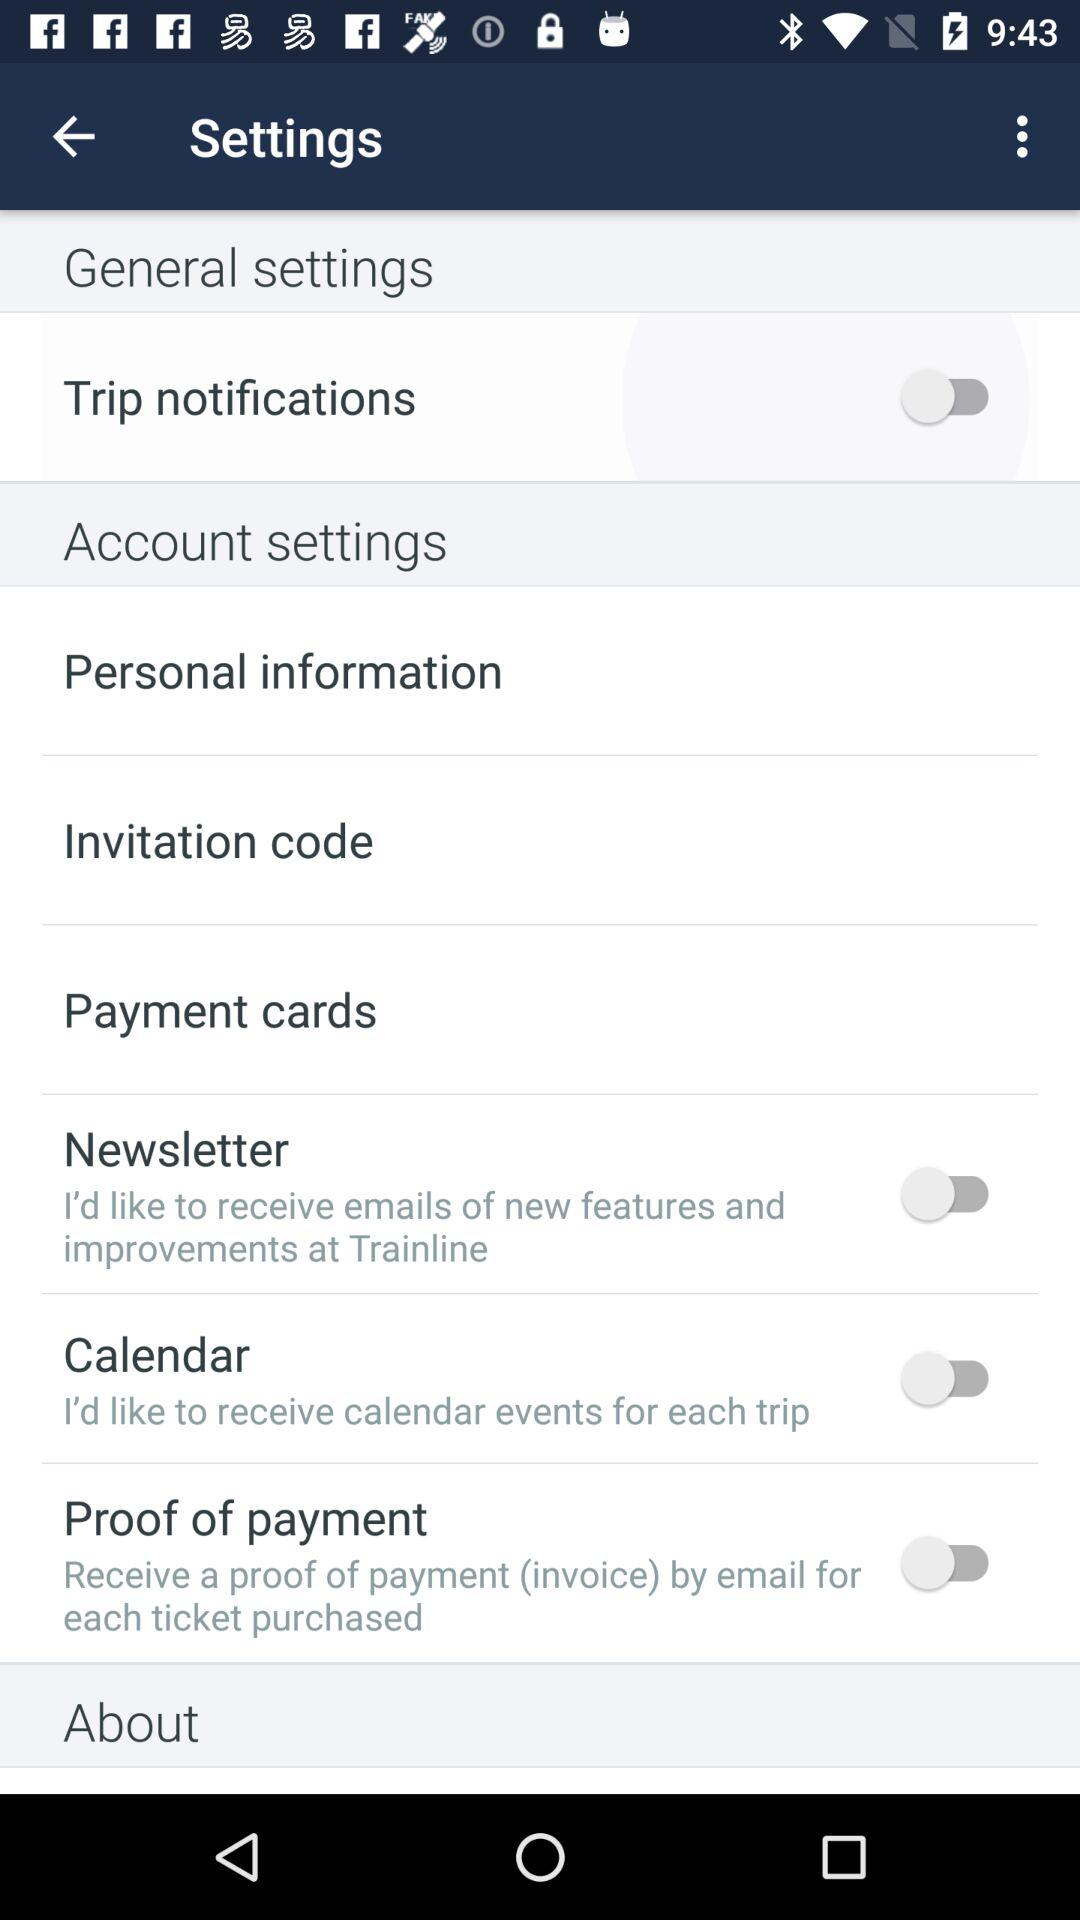What is the status of "Trip notifications"? The status is "off". 